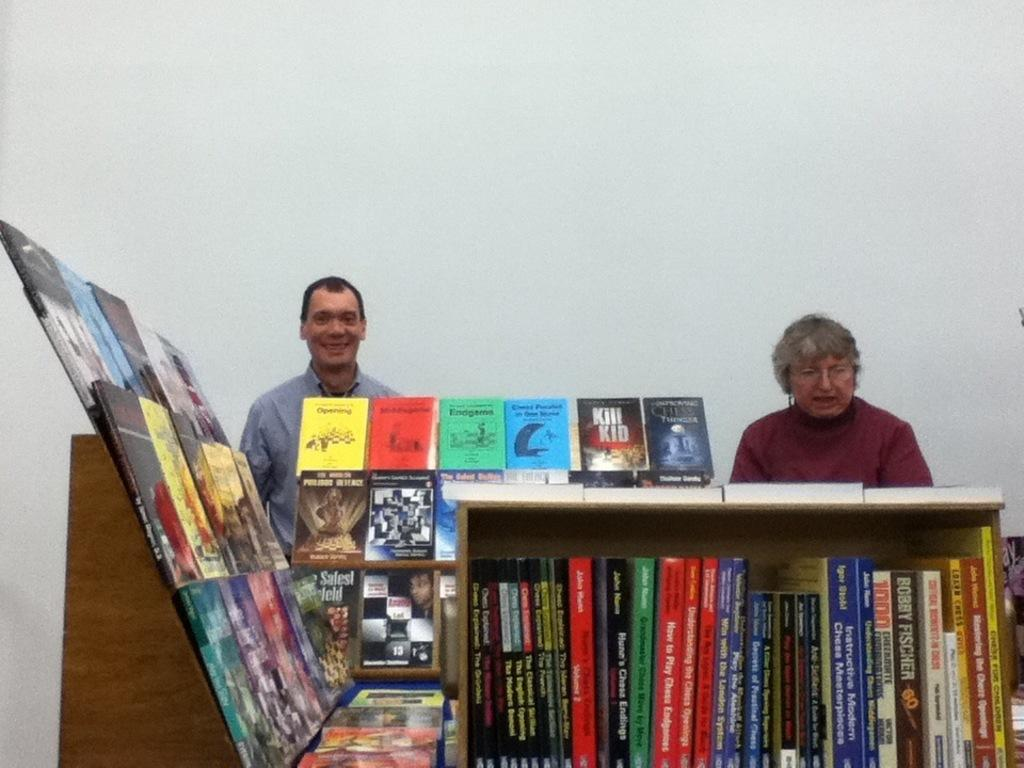<image>
Relay a brief, clear account of the picture shown. A man and woman are behind a bookshelf with books on it including one titled Kill Kid. 